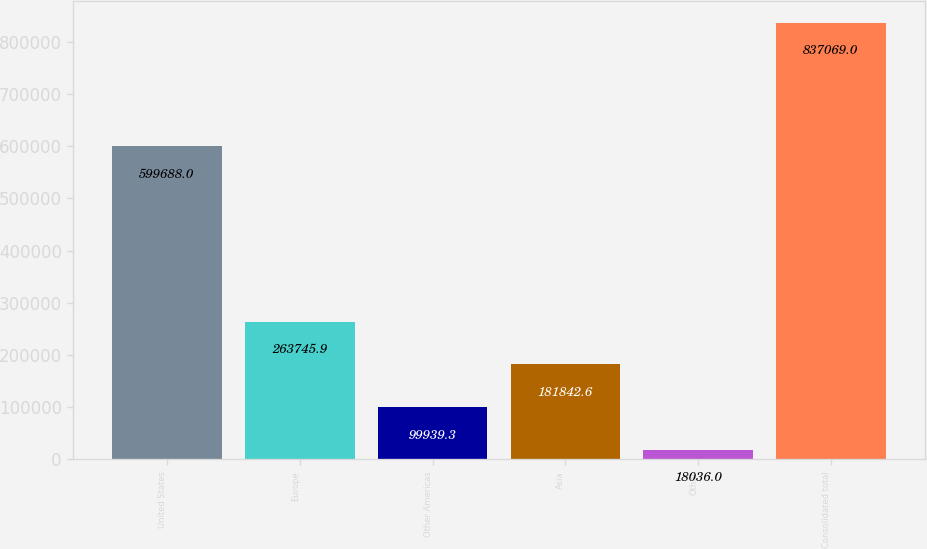Convert chart. <chart><loc_0><loc_0><loc_500><loc_500><bar_chart><fcel>United States<fcel>Europe<fcel>Other Americas<fcel>Asia<fcel>Other<fcel>Consolidated total<nl><fcel>599688<fcel>263746<fcel>99939.3<fcel>181843<fcel>18036<fcel>837069<nl></chart> 